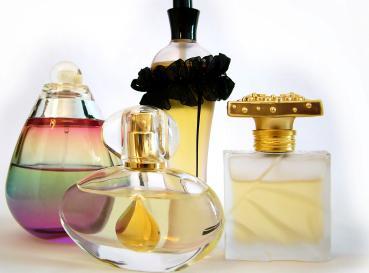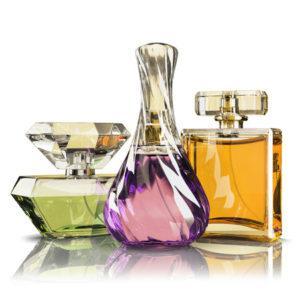The first image is the image on the left, the second image is the image on the right. For the images displayed, is the sentence "A single vial of perfume is standing in each of the images." factually correct? Answer yes or no. No. The first image is the image on the left, the second image is the image on the right. For the images displayed, is the sentence "Each image contains at least three different fragrance bottles." factually correct? Answer yes or no. Yes. 